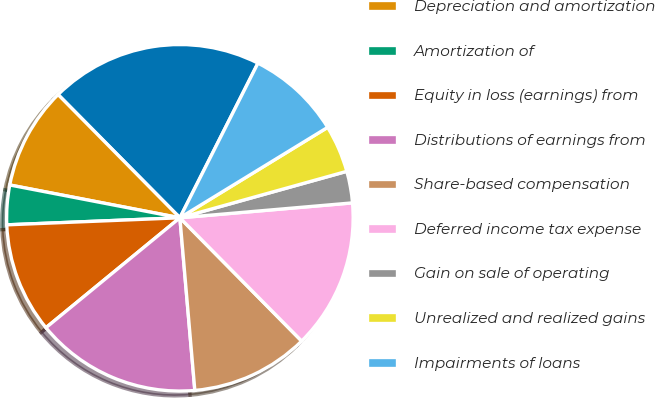Convert chart. <chart><loc_0><loc_0><loc_500><loc_500><pie_chart><fcel>Net earnings (including net<fcel>Depreciation and amortization<fcel>Amortization of<fcel>Equity in loss (earnings) from<fcel>Distributions of earnings from<fcel>Share-based compensation<fcel>Deferred income tax expense<fcel>Gain on sale of operating<fcel>Unrealized and realized gains<fcel>Impairments of loans<nl><fcel>19.85%<fcel>9.56%<fcel>3.68%<fcel>10.29%<fcel>15.44%<fcel>11.03%<fcel>13.97%<fcel>2.95%<fcel>4.42%<fcel>8.82%<nl></chart> 